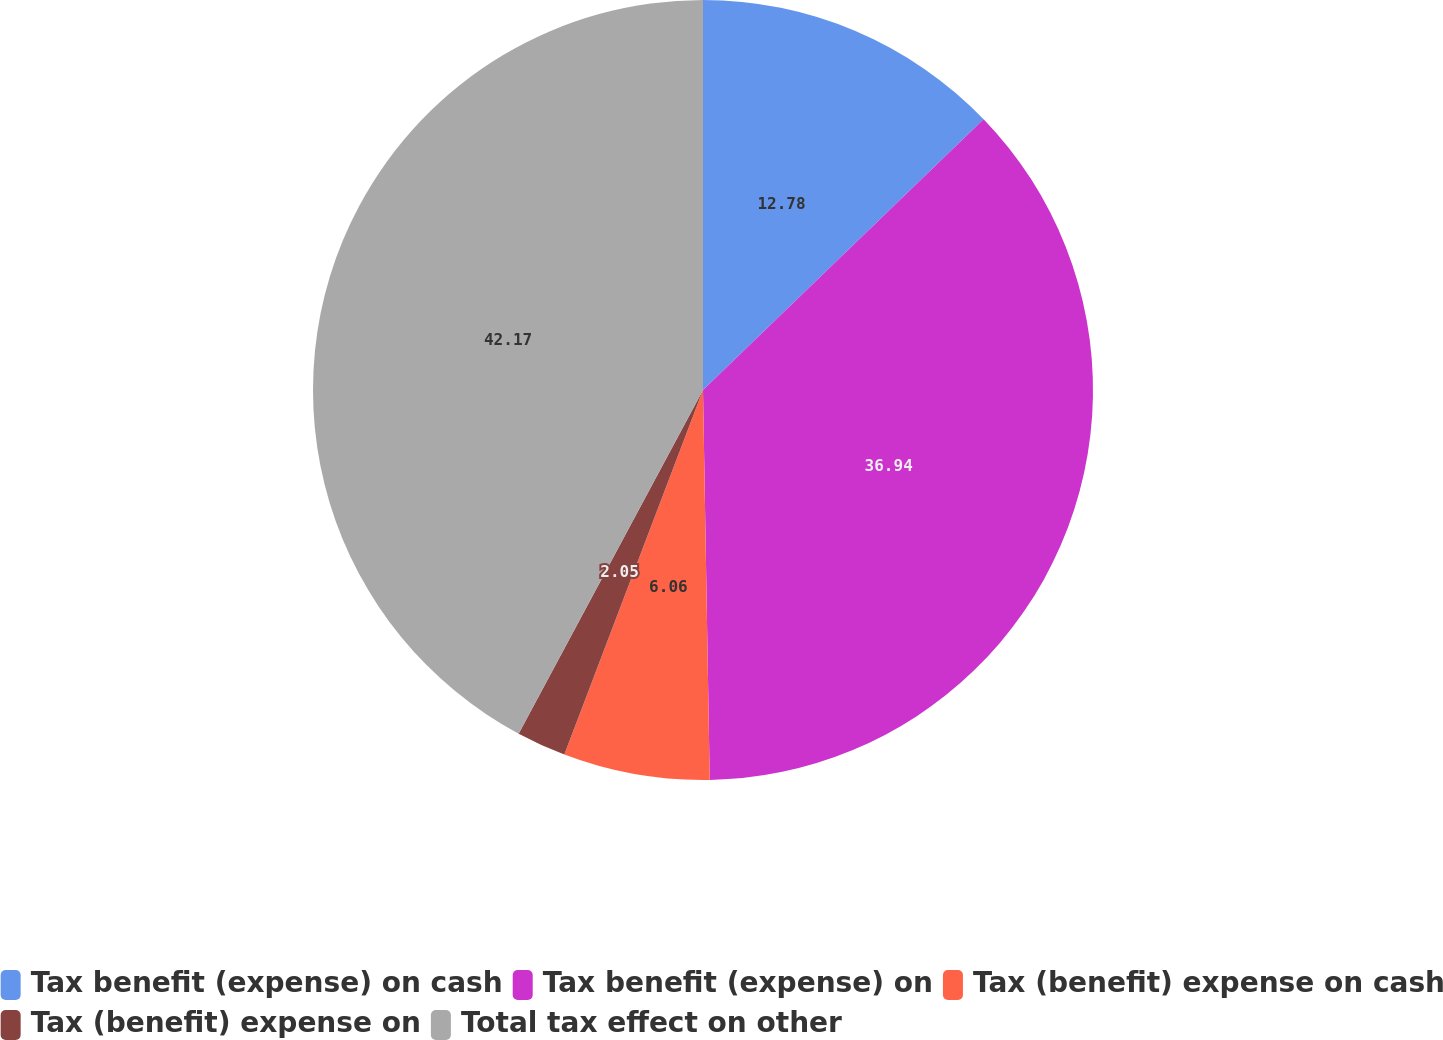Convert chart to OTSL. <chart><loc_0><loc_0><loc_500><loc_500><pie_chart><fcel>Tax benefit (expense) on cash<fcel>Tax benefit (expense) on<fcel>Tax (benefit) expense on cash<fcel>Tax (benefit) expense on<fcel>Total tax effect on other<nl><fcel>12.78%<fcel>36.94%<fcel>6.06%<fcel>2.05%<fcel>42.16%<nl></chart> 